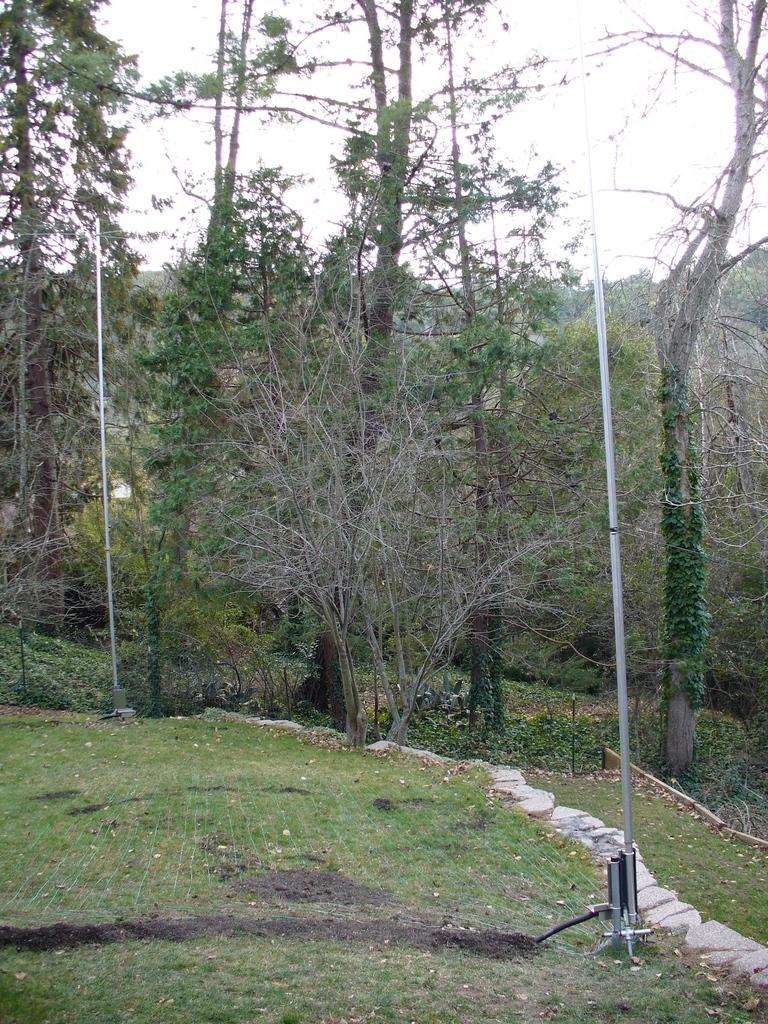What type of vegetation is in the foreground of the image? There is grass in the foreground of the image. What else can be seen in the foreground of the image besides grass? There are poles and trees in the foreground of the image. What is visible at the top of the image? The sky is visible at the top of the image. How many pigs are visible wearing hats in the image? There are no pigs or hats present in the image. What type of view can be seen from the top of the poles in the image? The image does not provide a view from the top of the poles, as it only shows the poles in the foreground. 